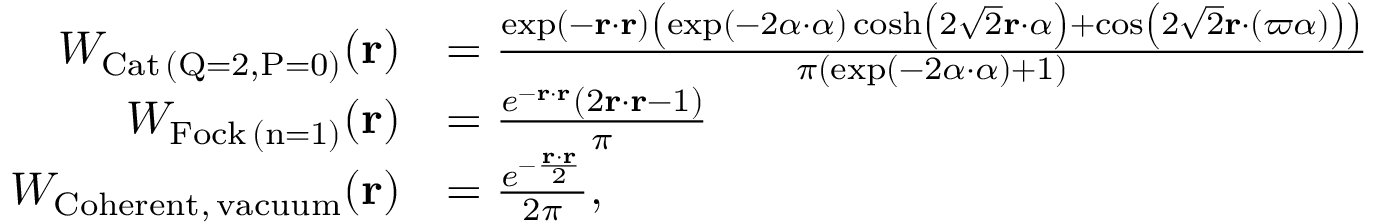Convert formula to latex. <formula><loc_0><loc_0><loc_500><loc_500>\begin{array} { r l } { W _ { C a t \, ( Q = 2 , P = 0 ) } ( r ) } & { = \frac { \exp ( - r \cdot r ) \left ( \exp ( - 2 \alpha \cdot \alpha ) \cosh \left ( 2 \sqrt { 2 } r \cdot \alpha \right ) + \cos \left ( 2 \sqrt { 2 } r \cdot ( \varpi \alpha ) \right ) \right ) } { \pi ( \exp ( - 2 \alpha \cdot \alpha ) + 1 ) } } \\ { W _ { F o c k \, ( n = 1 ) } ( r ) } & { = \frac { e ^ { - r \cdot r } \left ( 2 r \cdot r - 1 \right ) } { \pi } } \\ { W _ { C o h e r e n t , \, v a c u u m } ( r ) } & { = \frac { e ^ { - \frac { r \cdot r } { 2 } } } { 2 \pi } , } \end{array}</formula> 